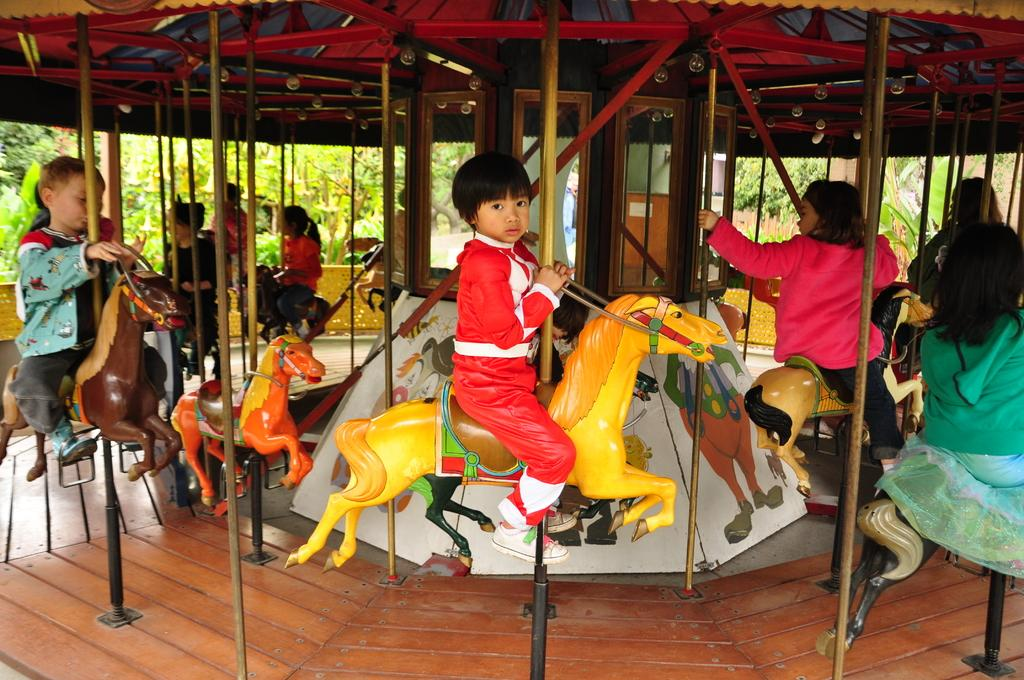What is the main subject of the picture? The main subject of the picture is a carousel. What are the kids doing on the carousel? Kids are sitting on horses in the carousel. What can be seen in the background of the picture? There are trees and a wall in the backdrop of the picture. What type of prose is being recited by the kids on the carousel? There is no indication in the image that the kids are reciting any prose. Can you see a pencil being used by any of the kids on the carousel? There is no pencil visible in the image. 